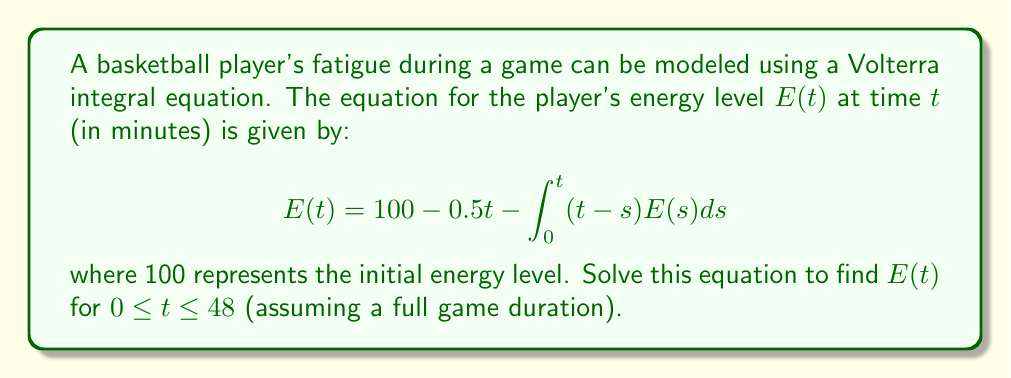Solve this math problem. To solve this Volterra integral equation, we'll use the following steps:

1) First, we differentiate both sides of the equation with respect to $t$:

   $$\frac{dE}{dt} = -0.5 - \int_0^t E(s)ds - (t-t)E(t) = -0.5 - \int_0^t E(s)ds$$

2) Differentiate again:

   $$\frac{d^2E}{dt^2} = -E(t)$$

3) We now have a second-order differential equation. To solve it, we need initial conditions:
   At $t=0$, $E(0) = 100$ (given in the original equation)
   At $t=0$, $\frac{dE}{dt}(0) = -0.5$ (from step 1)

4) The general solution to $\frac{d^2E}{dt^2} = -E(t)$ is:

   $$E(t) = A\cos(t) + B\sin(t)$$

5) Using the initial conditions:
   $E(0) = A = 100$
   $\frac{dE}{dt}(0) = B = -0.5$

6) Therefore, the solution is:

   $$E(t) = 100\cos(t) - 0.5\sin(t)$$

7) This solution is valid for $0 \leq t \leq 48$, covering the full game duration.
Answer: $E(t) = 100\cos(t) - 0.5\sin(t)$ 